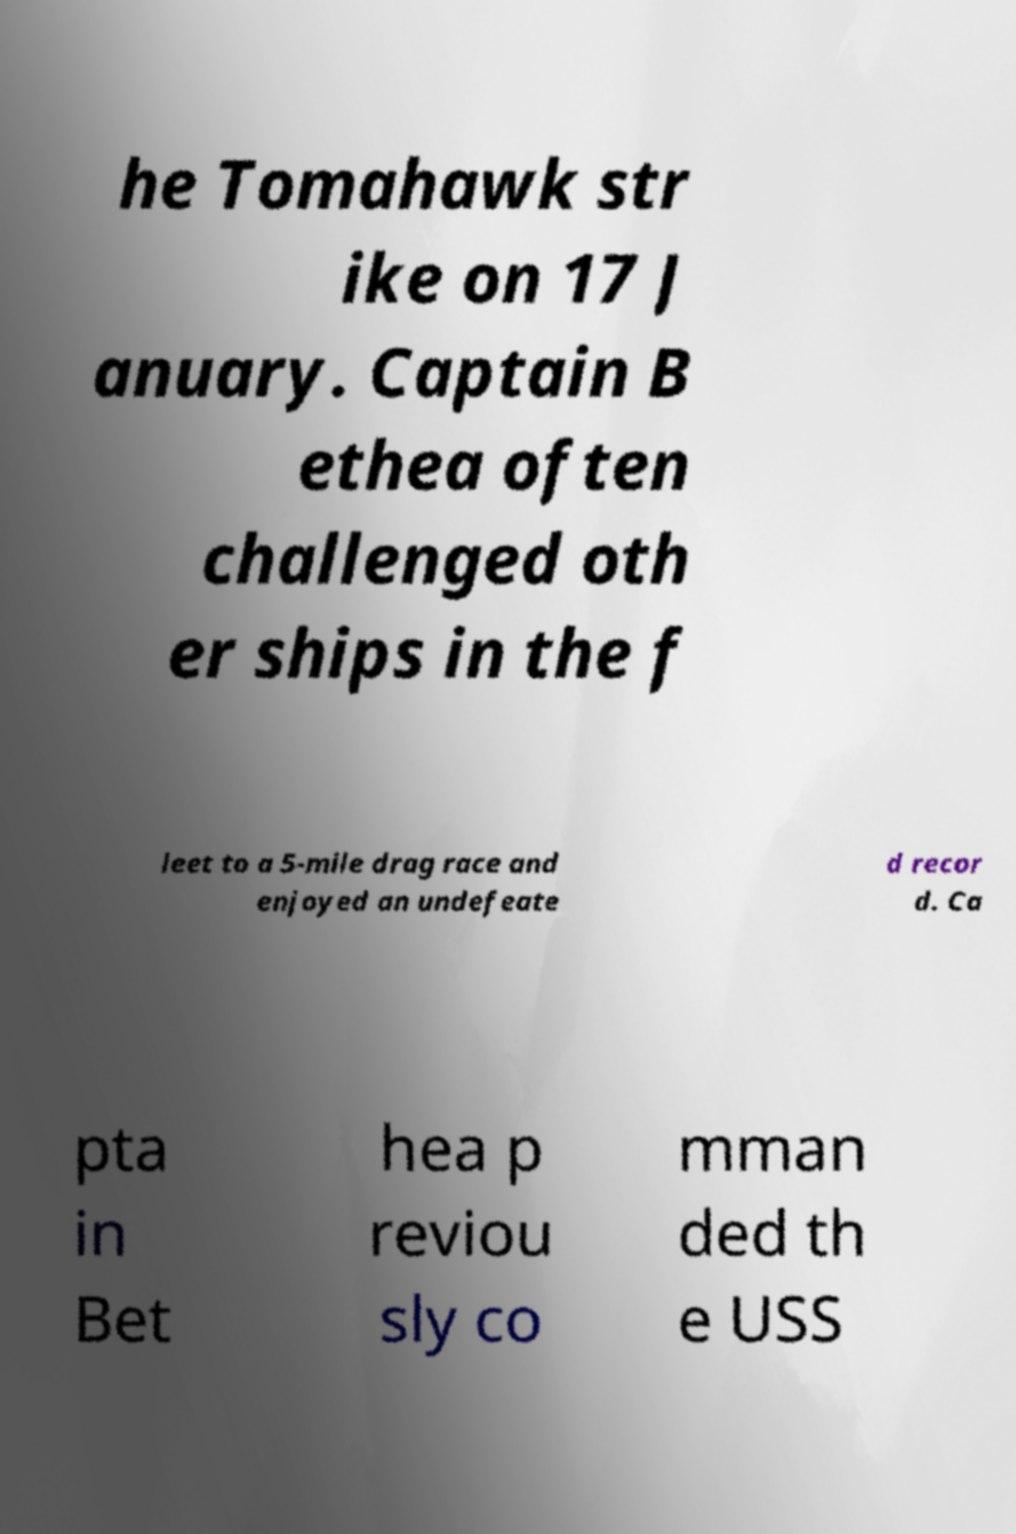There's text embedded in this image that I need extracted. Can you transcribe it verbatim? he Tomahawk str ike on 17 J anuary. Captain B ethea often challenged oth er ships in the f leet to a 5-mile drag race and enjoyed an undefeate d recor d. Ca pta in Bet hea p reviou sly co mman ded th e USS 